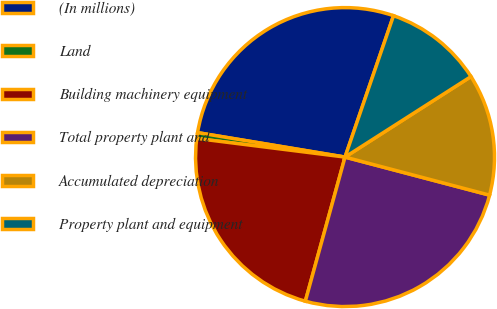Convert chart to OTSL. <chart><loc_0><loc_0><loc_500><loc_500><pie_chart><fcel>(In millions)<fcel>Land<fcel>Building machinery equipment<fcel>Total property plant and<fcel>Accumulated depreciation<fcel>Property plant and equipment<nl><fcel>27.64%<fcel>0.63%<fcel>22.71%<fcel>25.18%<fcel>13.15%<fcel>10.69%<nl></chart> 